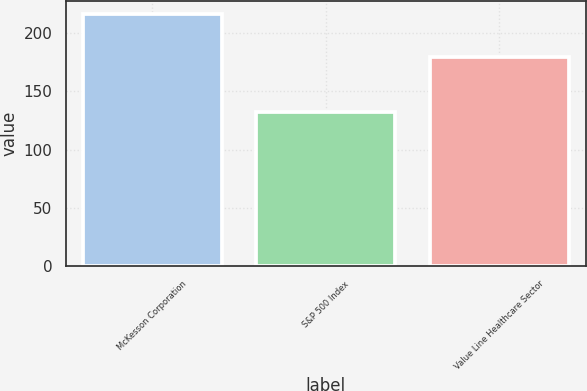Convert chart to OTSL. <chart><loc_0><loc_0><loc_500><loc_500><bar_chart><fcel>McKesson Corporation<fcel>S&P 500 Index<fcel>Value Line Healthcare Sector<nl><fcel>216.44<fcel>132.64<fcel>179.39<nl></chart> 